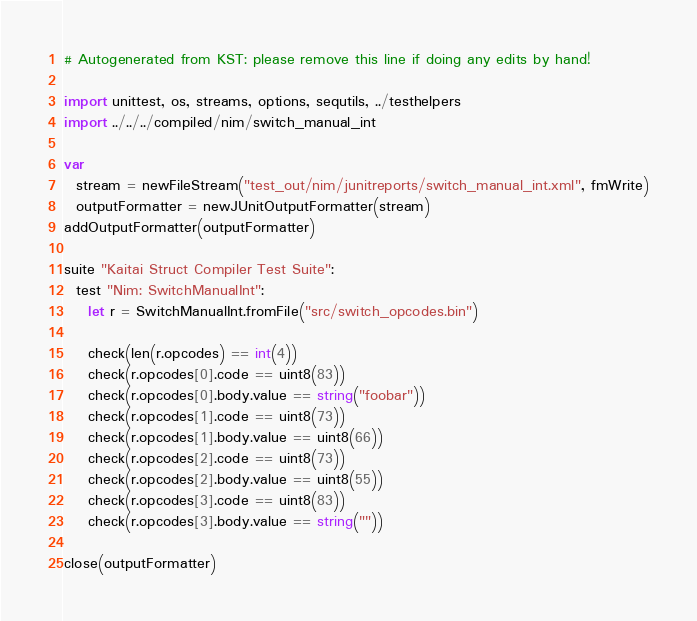Convert code to text. <code><loc_0><loc_0><loc_500><loc_500><_Nim_># Autogenerated from KST: please remove this line if doing any edits by hand!

import unittest, os, streams, options, sequtils, ../testhelpers
import ../../../compiled/nim/switch_manual_int

var
  stream = newFileStream("test_out/nim/junitreports/switch_manual_int.xml", fmWrite)
  outputFormatter = newJUnitOutputFormatter(stream)
addOutputFormatter(outputFormatter)

suite "Kaitai Struct Compiler Test Suite":
  test "Nim: SwitchManualInt":
    let r = SwitchManualInt.fromFile("src/switch_opcodes.bin")

    check(len(r.opcodes) == int(4))
    check(r.opcodes[0].code == uint8(83))
    check(r.opcodes[0].body.value == string("foobar"))
    check(r.opcodes[1].code == uint8(73))
    check(r.opcodes[1].body.value == uint8(66))
    check(r.opcodes[2].code == uint8(73))
    check(r.opcodes[2].body.value == uint8(55))
    check(r.opcodes[3].code == uint8(83))
    check(r.opcodes[3].body.value == string(""))

close(outputFormatter)
</code> 